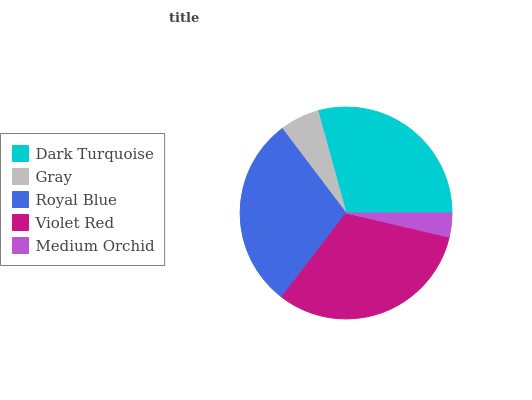Is Medium Orchid the minimum?
Answer yes or no. Yes. Is Violet Red the maximum?
Answer yes or no. Yes. Is Gray the minimum?
Answer yes or no. No. Is Gray the maximum?
Answer yes or no. No. Is Dark Turquoise greater than Gray?
Answer yes or no. Yes. Is Gray less than Dark Turquoise?
Answer yes or no. Yes. Is Gray greater than Dark Turquoise?
Answer yes or no. No. Is Dark Turquoise less than Gray?
Answer yes or no. No. Is Dark Turquoise the high median?
Answer yes or no. Yes. Is Dark Turquoise the low median?
Answer yes or no. Yes. Is Violet Red the high median?
Answer yes or no. No. Is Gray the low median?
Answer yes or no. No. 